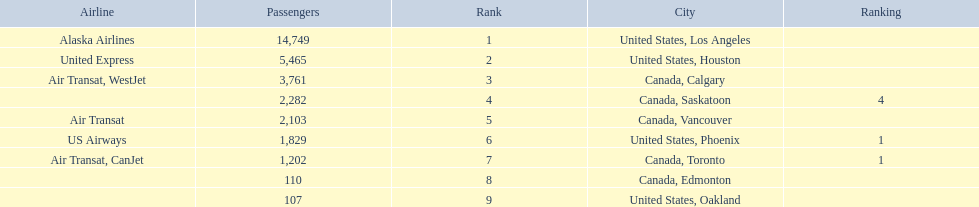What numbers are in the passengers column? 14,749, 5,465, 3,761, 2,282, 2,103, 1,829, 1,202, 110, 107. Parse the full table. {'header': ['Airline', 'Passengers', 'Rank', 'City', 'Ranking'], 'rows': [['Alaska Airlines', '14,749', '1', 'United States, Los Angeles', ''], ['United Express', '5,465', '2', 'United States, Houston', ''], ['Air Transat, WestJet', '3,761', '3', 'Canada, Calgary', ''], ['', '2,282', '4', 'Canada, Saskatoon', '4'], ['Air Transat', '2,103', '5', 'Canada, Vancouver', ''], ['US Airways', '1,829', '6', 'United States, Phoenix', '1'], ['Air Transat, CanJet', '1,202', '7', 'Canada, Toronto', '1'], ['', '110', '8', 'Canada, Edmonton', ''], ['', '107', '9', 'United States, Oakland', '']]} Which number is the lowest number in the passengers column? 107. What city is associated with this number? United States, Oakland. 